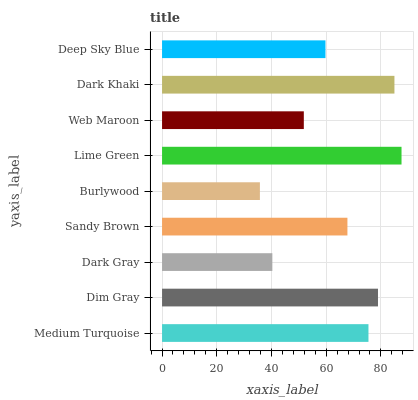Is Burlywood the minimum?
Answer yes or no. Yes. Is Lime Green the maximum?
Answer yes or no. Yes. Is Dim Gray the minimum?
Answer yes or no. No. Is Dim Gray the maximum?
Answer yes or no. No. Is Dim Gray greater than Medium Turquoise?
Answer yes or no. Yes. Is Medium Turquoise less than Dim Gray?
Answer yes or no. Yes. Is Medium Turquoise greater than Dim Gray?
Answer yes or no. No. Is Dim Gray less than Medium Turquoise?
Answer yes or no. No. Is Sandy Brown the high median?
Answer yes or no. Yes. Is Sandy Brown the low median?
Answer yes or no. Yes. Is Deep Sky Blue the high median?
Answer yes or no. No. Is Web Maroon the low median?
Answer yes or no. No. 